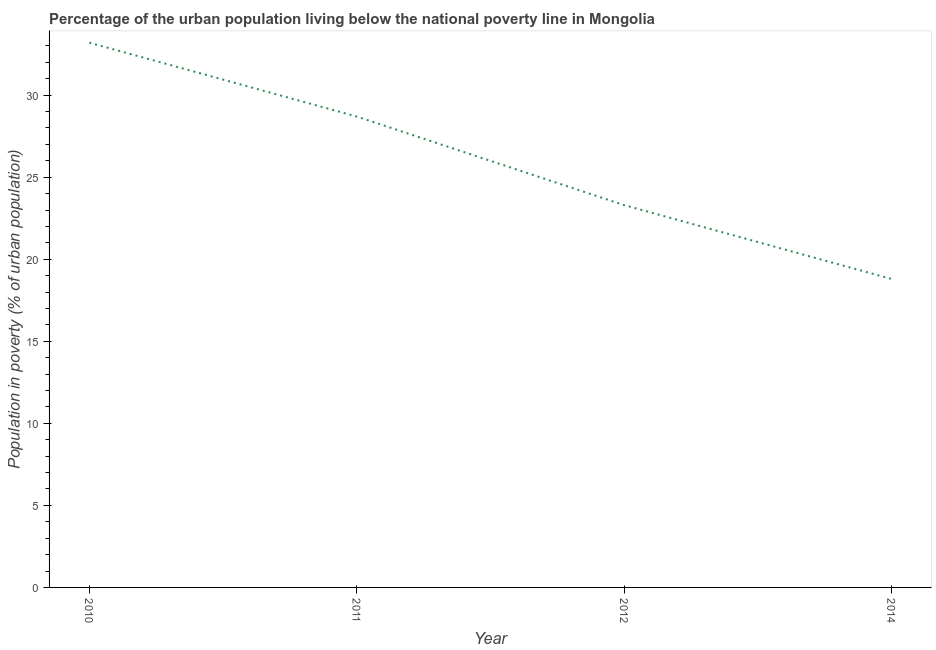What is the percentage of urban population living below poverty line in 2012?
Provide a short and direct response. 23.3. Across all years, what is the maximum percentage of urban population living below poverty line?
Offer a very short reply. 33.2. Across all years, what is the minimum percentage of urban population living below poverty line?
Ensure brevity in your answer.  18.8. In which year was the percentage of urban population living below poverty line maximum?
Give a very brief answer. 2010. In which year was the percentage of urban population living below poverty line minimum?
Provide a short and direct response. 2014. What is the sum of the percentage of urban population living below poverty line?
Keep it short and to the point. 104. What is the difference between the percentage of urban population living below poverty line in 2011 and 2014?
Make the answer very short. 9.9. What is the median percentage of urban population living below poverty line?
Your answer should be compact. 26. In how many years, is the percentage of urban population living below poverty line greater than 27 %?
Ensure brevity in your answer.  2. Do a majority of the years between 2011 and 2012 (inclusive) have percentage of urban population living below poverty line greater than 22 %?
Make the answer very short. Yes. What is the ratio of the percentage of urban population living below poverty line in 2010 to that in 2011?
Provide a short and direct response. 1.16. Is the difference between the percentage of urban population living below poverty line in 2010 and 2011 greater than the difference between any two years?
Make the answer very short. No. What is the difference between the highest and the second highest percentage of urban population living below poverty line?
Provide a succinct answer. 4.5. Is the sum of the percentage of urban population living below poverty line in 2010 and 2012 greater than the maximum percentage of urban population living below poverty line across all years?
Keep it short and to the point. Yes. What is the difference between the highest and the lowest percentage of urban population living below poverty line?
Offer a terse response. 14.4. In how many years, is the percentage of urban population living below poverty line greater than the average percentage of urban population living below poverty line taken over all years?
Your answer should be compact. 2. What is the difference between two consecutive major ticks on the Y-axis?
Provide a succinct answer. 5. Are the values on the major ticks of Y-axis written in scientific E-notation?
Ensure brevity in your answer.  No. What is the title of the graph?
Ensure brevity in your answer.  Percentage of the urban population living below the national poverty line in Mongolia. What is the label or title of the Y-axis?
Provide a short and direct response. Population in poverty (% of urban population). What is the Population in poverty (% of urban population) of 2010?
Provide a short and direct response. 33.2. What is the Population in poverty (% of urban population) in 2011?
Make the answer very short. 28.7. What is the Population in poverty (% of urban population) in 2012?
Your response must be concise. 23.3. What is the difference between the Population in poverty (% of urban population) in 2010 and 2011?
Your response must be concise. 4.5. What is the difference between the Population in poverty (% of urban population) in 2011 and 2012?
Give a very brief answer. 5.4. What is the difference between the Population in poverty (% of urban population) in 2012 and 2014?
Offer a very short reply. 4.5. What is the ratio of the Population in poverty (% of urban population) in 2010 to that in 2011?
Your response must be concise. 1.16. What is the ratio of the Population in poverty (% of urban population) in 2010 to that in 2012?
Keep it short and to the point. 1.43. What is the ratio of the Population in poverty (% of urban population) in 2010 to that in 2014?
Provide a succinct answer. 1.77. What is the ratio of the Population in poverty (% of urban population) in 2011 to that in 2012?
Your answer should be compact. 1.23. What is the ratio of the Population in poverty (% of urban population) in 2011 to that in 2014?
Your answer should be very brief. 1.53. What is the ratio of the Population in poverty (% of urban population) in 2012 to that in 2014?
Provide a succinct answer. 1.24. 